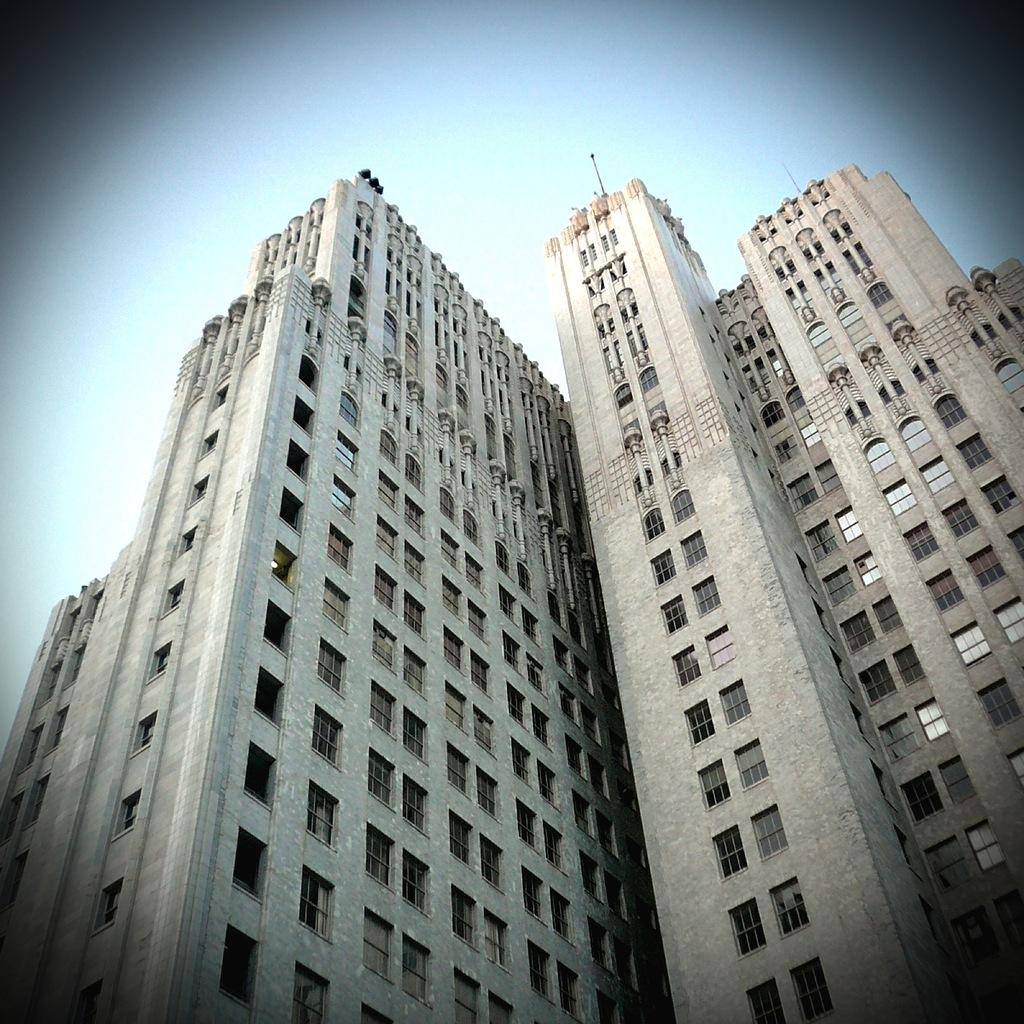What structures are present in the image? There are buildings in the image. What part of the natural environment is visible in the image? The sky is visible in the background of the image. Can you see a giraffe wearing a crown in the image? No, there is no giraffe or crown present in the image. Is the grandmother in the image holding a cup of tea? There is no reference to a grandmother or a cup of tea in the image, so it is not possible to answer that question. 